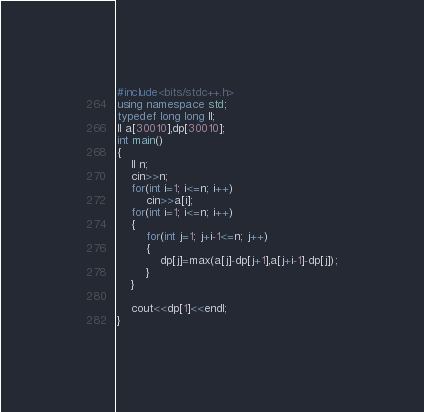<code> <loc_0><loc_0><loc_500><loc_500><_C++_>#include<bits/stdc++.h>
using namespace std;
typedef long long ll;
ll a[30010],dp[30010];
int main()
{
    ll n;
    cin>>n;
    for(int i=1; i<=n; i++)
        cin>>a[i];
    for(int i=1; i<=n; i++)
    {
        for(int j=1; j+i-1<=n; j++)
        {
            dp[j]=max(a[j]-dp[j+1],a[j+i-1]-dp[j]);
        }
    }

    cout<<dp[1]<<endl;
}
</code> 